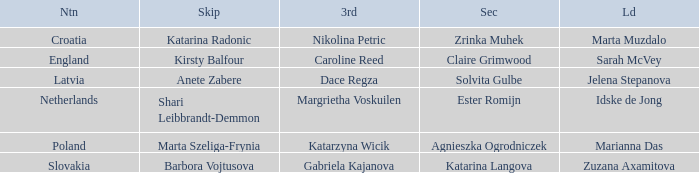What is the name of the second who has Caroline Reed as third? Claire Grimwood. 